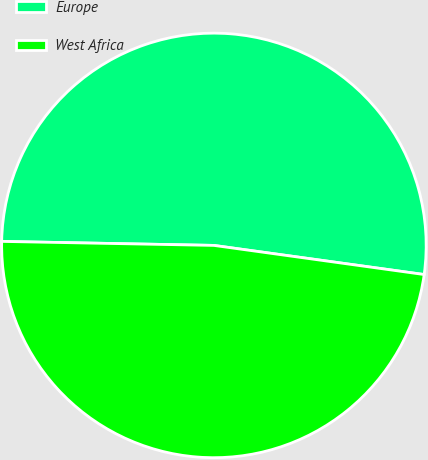Convert chart to OTSL. <chart><loc_0><loc_0><loc_500><loc_500><pie_chart><fcel>Europe<fcel>West Africa<nl><fcel>51.89%<fcel>48.11%<nl></chart> 